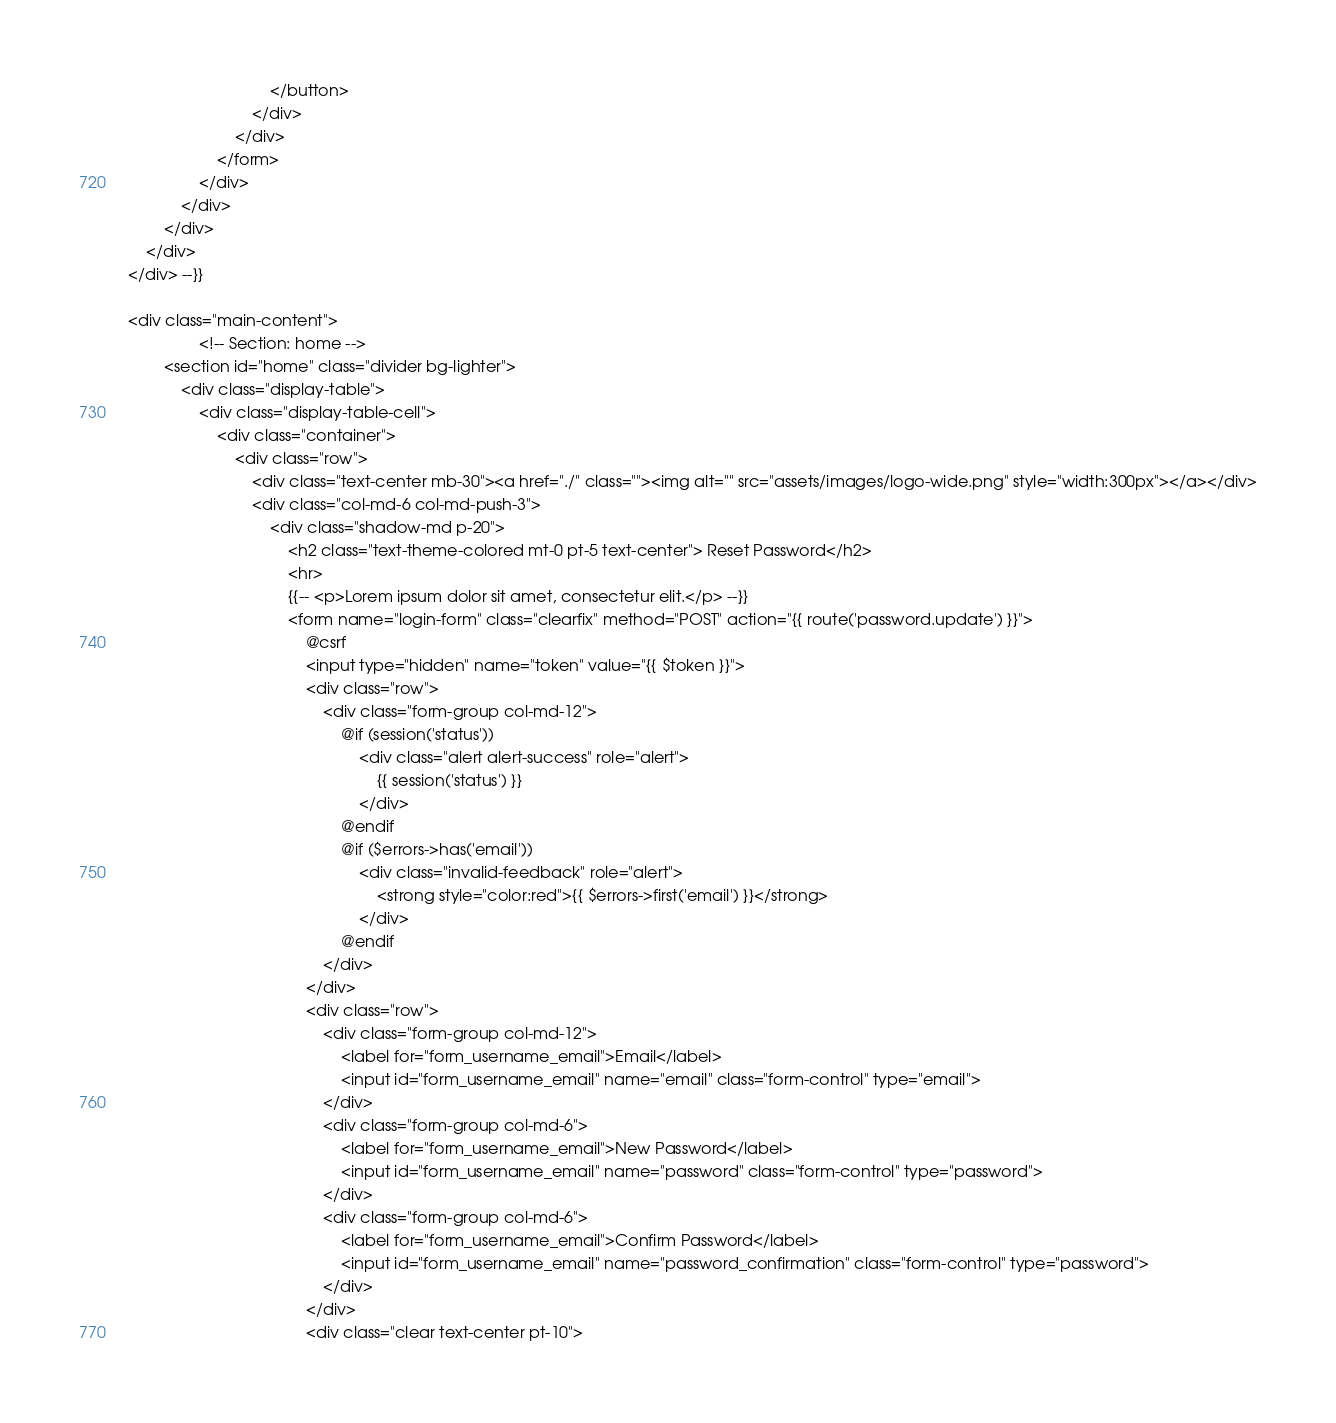<code> <loc_0><loc_0><loc_500><loc_500><_PHP_>                                </button>
                            </div>
                        </div>
                    </form>
                </div>
            </div>
        </div>
    </div>
</div> --}}

<div class="main-content">
                <!-- Section: home -->
        <section id="home" class="divider bg-lighter">
            <div class="display-table">
                <div class="display-table-cell">
                    <div class="container">
                        <div class="row">
                            <div class="text-center mb-30"><a href="./" class=""><img alt="" src="assets/images/logo-wide.png" style="width:300px"></a></div>
                            <div class="col-md-6 col-md-push-3">
                                <div class="shadow-md p-20">
                                    <h2 class="text-theme-colored mt-0 pt-5 text-center"> Reset Password</h2>
                                    <hr>
                                    {{-- <p>Lorem ipsum dolor sit amet, consectetur elit.</p> --}}
                                    <form name="login-form" class="clearfix" method="POST" action="{{ route('password.update') }}">
                                        @csrf
                                        <input type="hidden" name="token" value="{{ $token }}">
                                        <div class="row">
                                            <div class="form-group col-md-12">
                                                @if (session('status'))
                                                    <div class="alert alert-success" role="alert">
                                                        {{ session('status') }}
                                                    </div>
                                                @endif
                                                @if ($errors->has('email'))
                                                    <div class="invalid-feedback" role="alert">
                                                        <strong style="color:red">{{ $errors->first('email') }}</strong>
                                                    </div>
                                                @endif
                                            </div>
                                        </div>
                                        <div class="row">
                                            <div class="form-group col-md-12">
                                                <label for="form_username_email">Email</label>
                                                <input id="form_username_email" name="email" class="form-control" type="email">
                                            </div>
                                            <div class="form-group col-md-6">
                                                <label for="form_username_email">New Password</label>
                                                <input id="form_username_email" name="password" class="form-control" type="password">
                                            </div>
                                            <div class="form-group col-md-6">
                                                <label for="form_username_email">Confirm Password</label>
                                                <input id="form_username_email" name="password_confirmation" class="form-control" type="password">
                                            </div>
                                        </div>
                                        <div class="clear text-center pt-10"></code> 